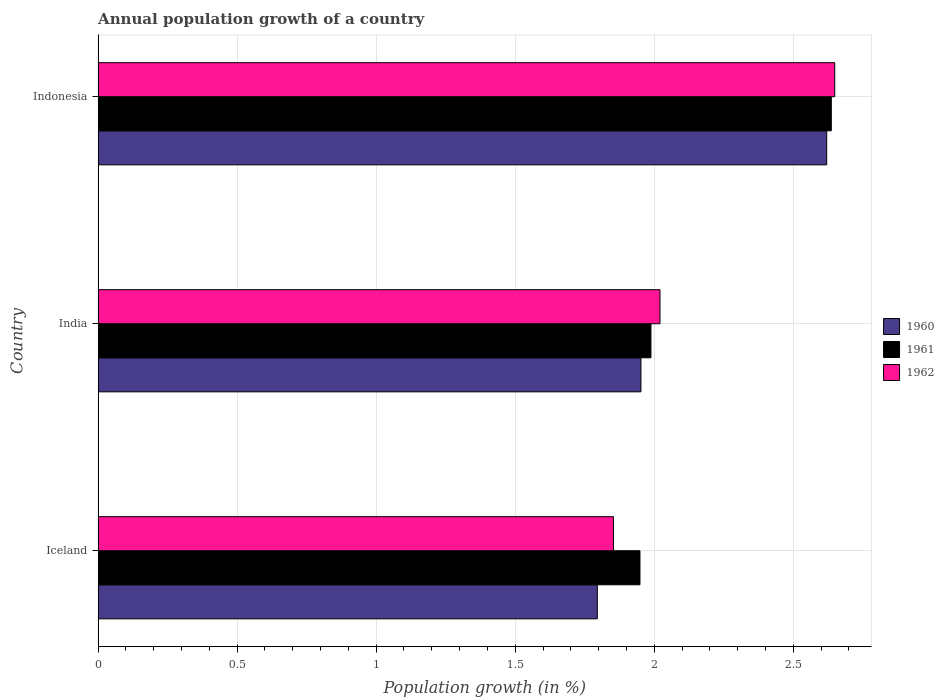How many different coloured bars are there?
Provide a short and direct response. 3. How many bars are there on the 2nd tick from the bottom?
Your response must be concise. 3. What is the label of the 1st group of bars from the top?
Provide a succinct answer. Indonesia. In how many cases, is the number of bars for a given country not equal to the number of legend labels?
Your answer should be very brief. 0. What is the annual population growth in 1961 in Iceland?
Your answer should be very brief. 1.95. Across all countries, what is the maximum annual population growth in 1960?
Provide a short and direct response. 2.62. Across all countries, what is the minimum annual population growth in 1962?
Provide a short and direct response. 1.85. What is the total annual population growth in 1961 in the graph?
Make the answer very short. 6.57. What is the difference between the annual population growth in 1962 in Iceland and that in Indonesia?
Give a very brief answer. -0.8. What is the difference between the annual population growth in 1961 in India and the annual population growth in 1962 in Indonesia?
Provide a succinct answer. -0.66. What is the average annual population growth in 1960 per country?
Offer a terse response. 2.12. What is the difference between the annual population growth in 1962 and annual population growth in 1961 in Iceland?
Offer a very short reply. -0.1. In how many countries, is the annual population growth in 1960 greater than 1.8 %?
Offer a very short reply. 2. What is the ratio of the annual population growth in 1961 in Iceland to that in India?
Offer a terse response. 0.98. Is the annual population growth in 1962 in Iceland less than that in India?
Provide a short and direct response. Yes. What is the difference between the highest and the second highest annual population growth in 1962?
Make the answer very short. 0.63. What is the difference between the highest and the lowest annual population growth in 1961?
Your response must be concise. 0.69. In how many countries, is the annual population growth in 1960 greater than the average annual population growth in 1960 taken over all countries?
Offer a terse response. 1. What does the 3rd bar from the bottom in Indonesia represents?
Provide a short and direct response. 1962. Is it the case that in every country, the sum of the annual population growth in 1962 and annual population growth in 1960 is greater than the annual population growth in 1961?
Give a very brief answer. Yes. What is the difference between two consecutive major ticks on the X-axis?
Ensure brevity in your answer.  0.5. Does the graph contain any zero values?
Make the answer very short. No. Where does the legend appear in the graph?
Your answer should be compact. Center right. What is the title of the graph?
Keep it short and to the point. Annual population growth of a country. What is the label or title of the X-axis?
Your answer should be compact. Population growth (in %). What is the label or title of the Y-axis?
Your answer should be very brief. Country. What is the Population growth (in %) in 1960 in Iceland?
Your response must be concise. 1.8. What is the Population growth (in %) in 1961 in Iceland?
Make the answer very short. 1.95. What is the Population growth (in %) of 1962 in Iceland?
Offer a very short reply. 1.85. What is the Population growth (in %) of 1960 in India?
Make the answer very short. 1.95. What is the Population growth (in %) of 1961 in India?
Give a very brief answer. 1.99. What is the Population growth (in %) in 1962 in India?
Offer a terse response. 2.02. What is the Population growth (in %) of 1960 in Indonesia?
Your answer should be very brief. 2.62. What is the Population growth (in %) in 1961 in Indonesia?
Ensure brevity in your answer.  2.64. What is the Population growth (in %) in 1962 in Indonesia?
Offer a very short reply. 2.65. Across all countries, what is the maximum Population growth (in %) in 1960?
Your response must be concise. 2.62. Across all countries, what is the maximum Population growth (in %) in 1961?
Give a very brief answer. 2.64. Across all countries, what is the maximum Population growth (in %) of 1962?
Keep it short and to the point. 2.65. Across all countries, what is the minimum Population growth (in %) in 1960?
Ensure brevity in your answer.  1.8. Across all countries, what is the minimum Population growth (in %) of 1961?
Your answer should be compact. 1.95. Across all countries, what is the minimum Population growth (in %) in 1962?
Offer a terse response. 1.85. What is the total Population growth (in %) in 1960 in the graph?
Offer a terse response. 6.37. What is the total Population growth (in %) in 1961 in the graph?
Your answer should be compact. 6.57. What is the total Population growth (in %) of 1962 in the graph?
Your answer should be very brief. 6.52. What is the difference between the Population growth (in %) of 1960 in Iceland and that in India?
Your response must be concise. -0.16. What is the difference between the Population growth (in %) in 1961 in Iceland and that in India?
Your answer should be very brief. -0.04. What is the difference between the Population growth (in %) in 1962 in Iceland and that in India?
Offer a very short reply. -0.17. What is the difference between the Population growth (in %) of 1960 in Iceland and that in Indonesia?
Provide a short and direct response. -0.82. What is the difference between the Population growth (in %) in 1961 in Iceland and that in Indonesia?
Make the answer very short. -0.69. What is the difference between the Population growth (in %) of 1962 in Iceland and that in Indonesia?
Make the answer very short. -0.8. What is the difference between the Population growth (in %) in 1960 in India and that in Indonesia?
Give a very brief answer. -0.67. What is the difference between the Population growth (in %) in 1961 in India and that in Indonesia?
Provide a short and direct response. -0.65. What is the difference between the Population growth (in %) in 1962 in India and that in Indonesia?
Keep it short and to the point. -0.63. What is the difference between the Population growth (in %) in 1960 in Iceland and the Population growth (in %) in 1961 in India?
Offer a terse response. -0.19. What is the difference between the Population growth (in %) of 1960 in Iceland and the Population growth (in %) of 1962 in India?
Offer a very short reply. -0.23. What is the difference between the Population growth (in %) in 1961 in Iceland and the Population growth (in %) in 1962 in India?
Offer a terse response. -0.07. What is the difference between the Population growth (in %) of 1960 in Iceland and the Population growth (in %) of 1961 in Indonesia?
Offer a very short reply. -0.84. What is the difference between the Population growth (in %) in 1960 in Iceland and the Population growth (in %) in 1962 in Indonesia?
Your response must be concise. -0.85. What is the difference between the Population growth (in %) in 1961 in Iceland and the Population growth (in %) in 1962 in Indonesia?
Your answer should be very brief. -0.7. What is the difference between the Population growth (in %) of 1960 in India and the Population growth (in %) of 1961 in Indonesia?
Make the answer very short. -0.68. What is the difference between the Population growth (in %) in 1960 in India and the Population growth (in %) in 1962 in Indonesia?
Offer a terse response. -0.7. What is the difference between the Population growth (in %) of 1961 in India and the Population growth (in %) of 1962 in Indonesia?
Give a very brief answer. -0.66. What is the average Population growth (in %) in 1960 per country?
Ensure brevity in your answer.  2.12. What is the average Population growth (in %) of 1961 per country?
Provide a short and direct response. 2.19. What is the average Population growth (in %) of 1962 per country?
Ensure brevity in your answer.  2.17. What is the difference between the Population growth (in %) of 1960 and Population growth (in %) of 1961 in Iceland?
Offer a terse response. -0.15. What is the difference between the Population growth (in %) of 1960 and Population growth (in %) of 1962 in Iceland?
Ensure brevity in your answer.  -0.06. What is the difference between the Population growth (in %) in 1961 and Population growth (in %) in 1962 in Iceland?
Keep it short and to the point. 0.1. What is the difference between the Population growth (in %) of 1960 and Population growth (in %) of 1961 in India?
Your response must be concise. -0.04. What is the difference between the Population growth (in %) of 1960 and Population growth (in %) of 1962 in India?
Provide a succinct answer. -0.07. What is the difference between the Population growth (in %) of 1961 and Population growth (in %) of 1962 in India?
Provide a succinct answer. -0.03. What is the difference between the Population growth (in %) in 1960 and Population growth (in %) in 1961 in Indonesia?
Ensure brevity in your answer.  -0.02. What is the difference between the Population growth (in %) of 1960 and Population growth (in %) of 1962 in Indonesia?
Your response must be concise. -0.03. What is the difference between the Population growth (in %) in 1961 and Population growth (in %) in 1962 in Indonesia?
Provide a succinct answer. -0.01. What is the ratio of the Population growth (in %) of 1960 in Iceland to that in India?
Give a very brief answer. 0.92. What is the ratio of the Population growth (in %) of 1961 in Iceland to that in India?
Make the answer very short. 0.98. What is the ratio of the Population growth (in %) in 1962 in Iceland to that in India?
Keep it short and to the point. 0.92. What is the ratio of the Population growth (in %) in 1960 in Iceland to that in Indonesia?
Provide a short and direct response. 0.69. What is the ratio of the Population growth (in %) of 1961 in Iceland to that in Indonesia?
Provide a succinct answer. 0.74. What is the ratio of the Population growth (in %) of 1962 in Iceland to that in Indonesia?
Ensure brevity in your answer.  0.7. What is the ratio of the Population growth (in %) in 1960 in India to that in Indonesia?
Offer a terse response. 0.74. What is the ratio of the Population growth (in %) of 1961 in India to that in Indonesia?
Your response must be concise. 0.75. What is the ratio of the Population growth (in %) in 1962 in India to that in Indonesia?
Give a very brief answer. 0.76. What is the difference between the highest and the second highest Population growth (in %) in 1960?
Ensure brevity in your answer.  0.67. What is the difference between the highest and the second highest Population growth (in %) in 1961?
Give a very brief answer. 0.65. What is the difference between the highest and the second highest Population growth (in %) of 1962?
Offer a terse response. 0.63. What is the difference between the highest and the lowest Population growth (in %) of 1960?
Offer a terse response. 0.82. What is the difference between the highest and the lowest Population growth (in %) in 1961?
Keep it short and to the point. 0.69. What is the difference between the highest and the lowest Population growth (in %) in 1962?
Offer a very short reply. 0.8. 